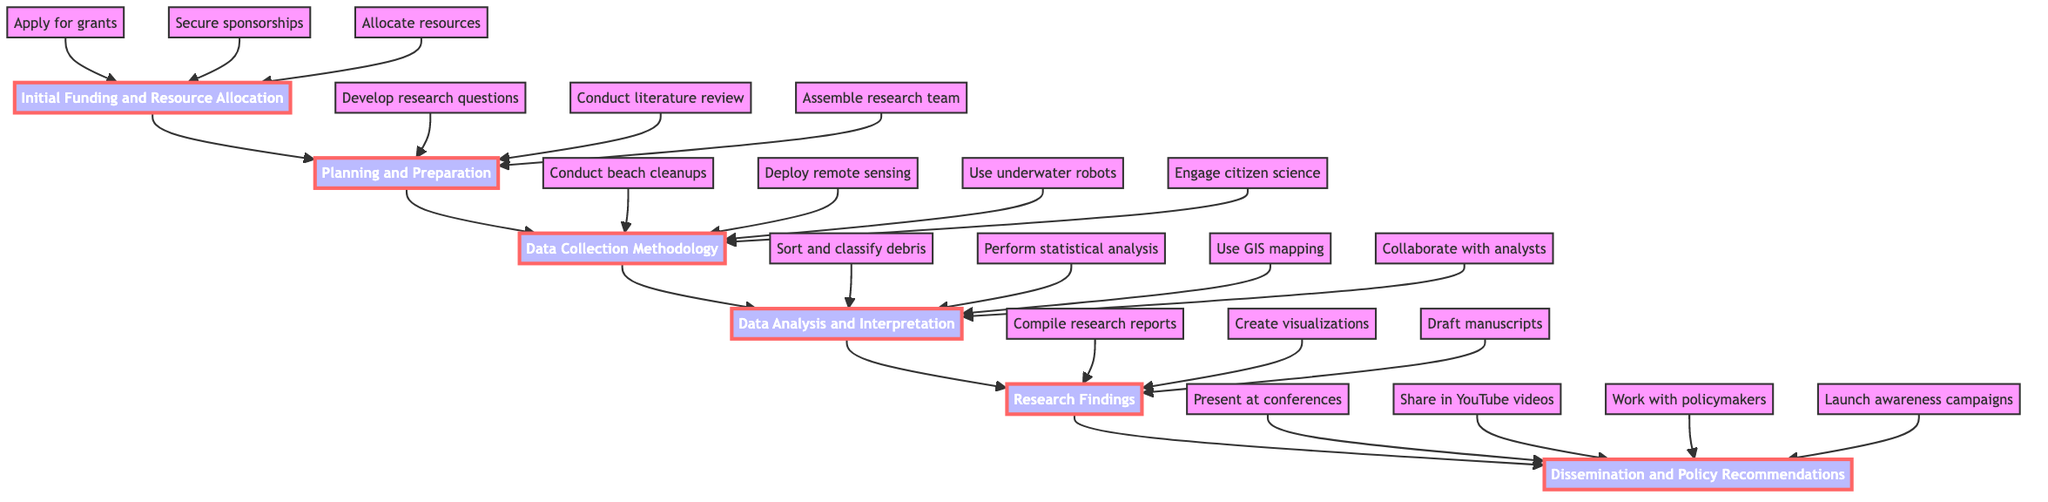What is the first stage in the process? The diagram indicates that the first stage in the process is "Initial Funding and Resource Allocation." It is the bottom node from which all other stages flow upwards.
Answer: Initial Funding and Resource Allocation How many stages are there in the process? By counting the nodes starting from "Initial Funding and Resource Allocation" at the bottom to "Dissemination and Policy Recommendations" at the top, we find that there are a total of six stages.
Answer: 6 What actions are taken during Planning and Preparation? According to the diagram, the actions during the "Planning and Preparation" stage include developing research questions, conducting a literature review, and assembling a research team. Each of these actions leads into this stage.
Answer: Develop research questions, conduct literature review, assemble research team Which stage comes after Data Analysis and Interpretation? The diagram shows that the stage following "Data Analysis and Interpretation" is "Research Findings." This is determined by following the upward chain from one node to the next in the flow.
Answer: Research Findings What kind of technology is deployed during Data Collection Methodology? The diagram lists several technologies used in "Data Collection Methodology," such as remote sensing technology like drones and underwater robots (ROVs). Both of these technologies are specifically mentioned in the actions for this stage.
Answer: Remote sensing technology, underwater robots How do the findings get disseminated? The diagram specifies that findings get disseminated through presenting at conferences, sharing in YouTube videos, working with policymakers, and launching awareness campaigns. Each of these methods is part of the final stage's actions.
Answer: Presenting at conferences, sharing in YouTube videos, working with policymakers, launching awareness campaigns Which node contains the action "Engage in citizen science programs"? In the flow chart, "Engage in citizen science programs" is listed as one of the actions in the "Data Collection Methodology" stage. This is identified by examining the actions listed under each respective stage.
Answer: Data Collection Methodology What is the main objective of the Research Findings stage? The primary objective of the "Research Findings" stage, as indicated in the diagram, is to compile comprehensive research reports, create visualizations, and draft manuscripts for scientific journals. These actions help achieve the purpose of reporting on research outcomes.
Answer: Compile comprehensive research reports, create visualizations, draft manuscripts 